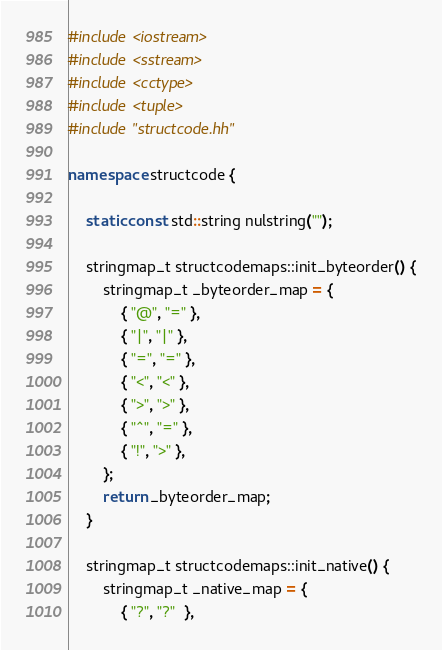<code> <loc_0><loc_0><loc_500><loc_500><_C++_>
#include <iostream>
#include <sstream>
#include <cctype>
#include <tuple>
#include "structcode.hh"

namespace structcode {
    
    static const std::string nulstring("");
    
    stringmap_t structcodemaps::init_byteorder() {
        stringmap_t _byteorder_map = {
            { "@", "=" },
            { "|", "|" },
            { "=", "=" },
            { "<", "<" },
            { ">", ">" },
            { "^", "=" },
            { "!", ">" },
        };
        return _byteorder_map;
    }
    
    stringmap_t structcodemaps::init_native() {
        stringmap_t _native_map = {
            { "?", "?"  },</code> 